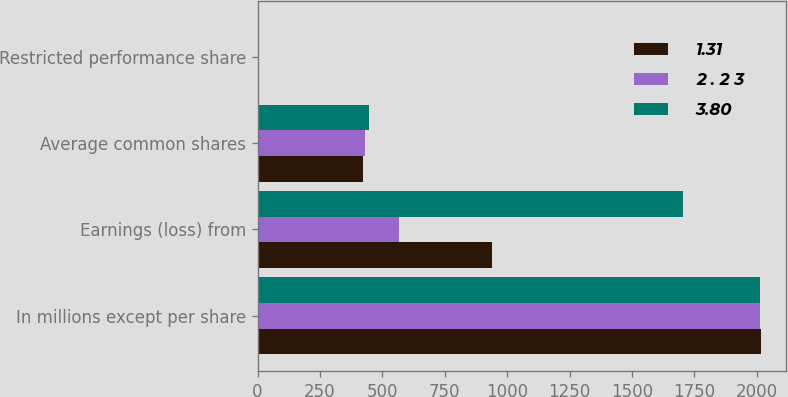Convert chart to OTSL. <chart><loc_0><loc_0><loc_500><loc_500><stacked_bar_chart><ecel><fcel>In millions except per share<fcel>Earnings (loss) from<fcel>Average common shares<fcel>Restricted performance share<nl><fcel>1.31<fcel>2015<fcel>938<fcel>420.6<fcel>3.2<nl><fcel>2 . 2 3<fcel>2014<fcel>568<fcel>432<fcel>4.2<nl><fcel>3.80<fcel>2013<fcel>1704<fcel>448.1<fcel>4.5<nl></chart> 